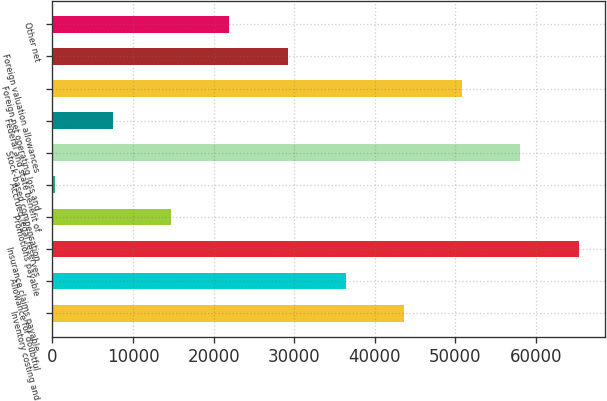Convert chart. <chart><loc_0><loc_0><loc_500><loc_500><bar_chart><fcel>Inventory costing and<fcel>Allowance for doubtful<fcel>Insurance claims payable<fcel>Promotions payable<fcel>Accrued legal reserves<fcel>Stock-based compensation<fcel>Federal and state benefit of<fcel>Foreign net operating loss and<fcel>Foreign valuation allowances<fcel>Other net<nl><fcel>43617.6<fcel>36399.5<fcel>65271.9<fcel>14745.2<fcel>309<fcel>58053.8<fcel>7527.1<fcel>50835.7<fcel>29181.4<fcel>21963.3<nl></chart> 